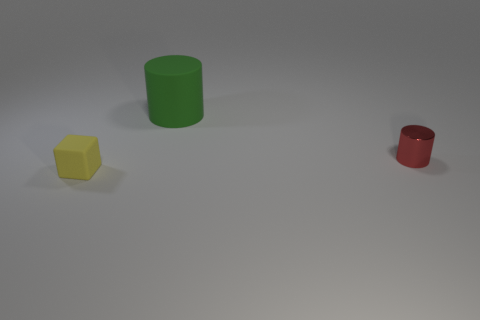Is there a big cylinder that has the same material as the small cube?
Ensure brevity in your answer.  Yes. What number of objects are either rubber objects that are behind the block or matte things that are on the left side of the big green matte cylinder?
Your answer should be compact. 2. What material is the small yellow object?
Give a very brief answer. Rubber. Do the object that is in front of the red shiny cylinder and the tiny red cylinder have the same size?
Keep it short and to the point. Yes. Is there anything else that has the same size as the green matte cylinder?
Ensure brevity in your answer.  No. What is the size of the green thing that is the same shape as the tiny red thing?
Your response must be concise. Large. Is the number of yellow matte blocks that are behind the yellow rubber object the same as the number of things to the right of the red cylinder?
Ensure brevity in your answer.  Yes. What size is the thing on the right side of the green rubber thing?
Give a very brief answer. Small. Is there any other thing that has the same shape as the small yellow object?
Your answer should be very brief. No. Is the number of large things behind the green matte thing the same as the number of tiny rubber things?
Keep it short and to the point. No. 